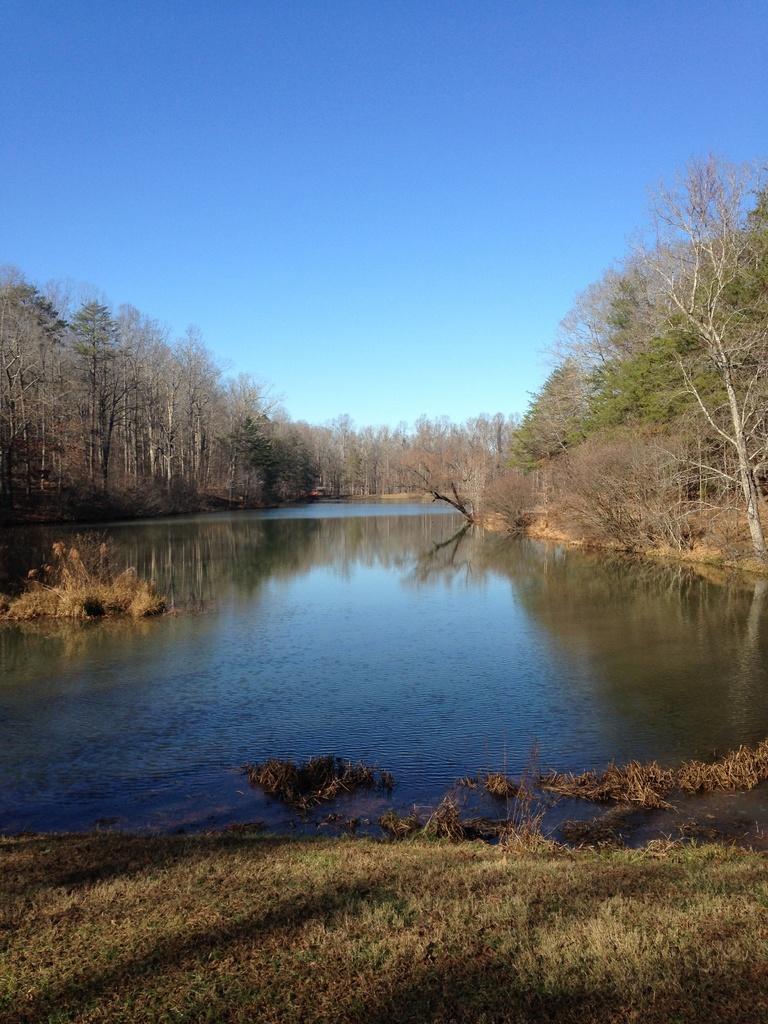Please provide a concise description of this image. In this picture I can see the grass in front and in the middle of this picture I can see the water and number of trees. In the background I can see the clear sky. 